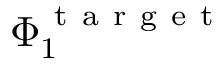<formula> <loc_0><loc_0><loc_500><loc_500>\Phi _ { 1 } ^ { t a r g e t }</formula> 